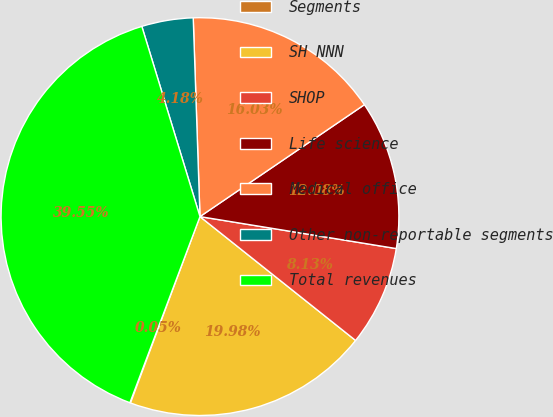<chart> <loc_0><loc_0><loc_500><loc_500><pie_chart><fcel>Segments<fcel>SH NNN<fcel>SHOP<fcel>Life science<fcel>Medical office<fcel>Other non-reportable segments<fcel>Total revenues<nl><fcel>0.05%<fcel>19.98%<fcel>8.13%<fcel>12.08%<fcel>16.03%<fcel>4.18%<fcel>39.55%<nl></chart> 